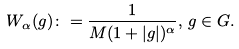Convert formula to latex. <formula><loc_0><loc_0><loc_500><loc_500>W _ { \alpha } ( g ) \colon = \frac { 1 } { M ( 1 + | g | ) ^ { \alpha } } , \, g \in G .</formula> 